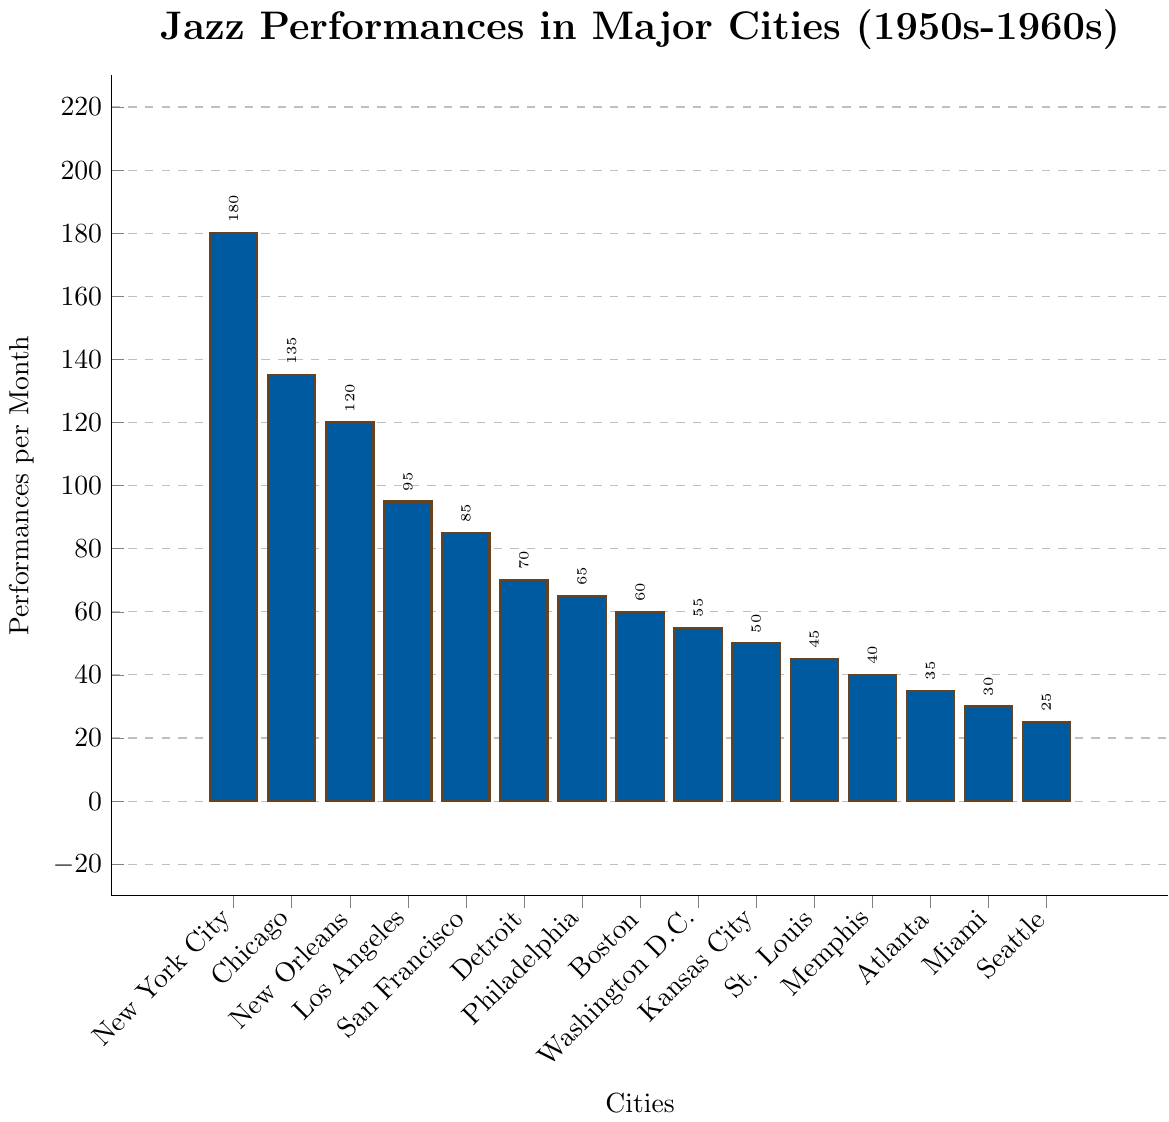What's the city with the highest number of jazz performances per month? The bar representing New York City is the tallest in the figure, indicating it has the highest number of jazz performances per month at 180.
Answer: New York City Which two cities have the closest number of jazz performances per month and what are their values? Comparing the bars visually, Boston and Philadelphia have similar heights, indicating close values at 60 and 65 performances per month respectively.
Answer: Boston (60), Philadelphia (65) What's the total number of jazz performances per month in the top 3 cities combined? New York City has 180, Chicago has 135, and New Orleans has 120. Adding these gives 180 + 135 + 120 = 435.
Answer: 435 What is the difference in the number of performances per month between the city with the highest and lowest values? New York City has 180 performances, and Seattle has 25 performances. The difference is 180 - 25 = 155.
Answer: 155 Which city has fewer performances per month, Detroit or Los Angeles, and by how much? Detroit has 70 performances, and Los Angeles has 95 performances. The difference is 95 - 70 = 25, so Detroit has fewer performances.
Answer: Detroit, 25 What is the average number of performances per month across all cities? The total sum of performances per month across all cities is 1080. There are 15 cities, so average is 1080/15 = 72.
Answer: 72 Arrange the following cities in descending order of jazz performances: Philadelphia, Miami, and Washington D.C. Washington D.C. has 55, Philadelphia has 65, and Miami has 30 performances. In descending order, it is Philadelphia, Washington D.C., Miami.
Answer: Philadelphia, Washington D.C., Miami What is the median number of jazz performances per month among the listed cities? The sorted list of performances is [25, 30, 35, 40, 45, 50, 55, 60, 65, 70, 85, 95, 120, 135, 180]. With 15 data points, the median is the 8th value: 60.
Answer: 60 How many more performances per month does New York City have compared to Los Angeles? New York City has 180 performances, and Los Angeles has 95 performances. The difference is 180 - 95 = 85.
Answer: 85 